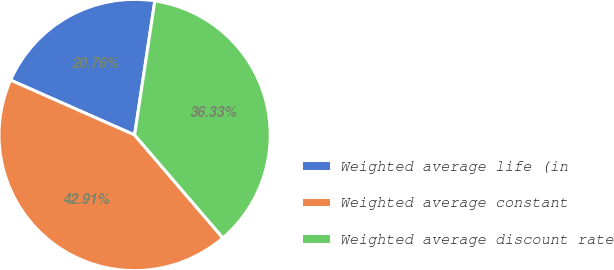<chart> <loc_0><loc_0><loc_500><loc_500><pie_chart><fcel>Weighted average life (in<fcel>Weighted average constant<fcel>Weighted average discount rate<nl><fcel>20.76%<fcel>42.91%<fcel>36.33%<nl></chart> 